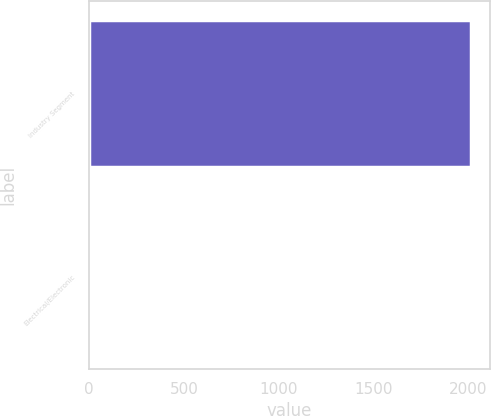Convert chart. <chart><loc_0><loc_0><loc_500><loc_500><bar_chart><fcel>Industry Segment<fcel>Electrical/Electronic<nl><fcel>2013<fcel>4<nl></chart> 